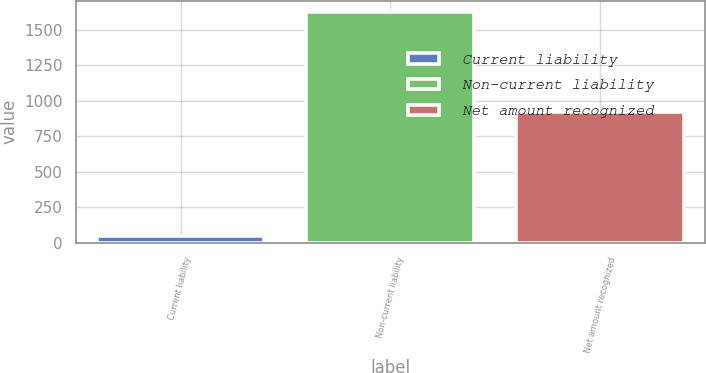Convert chart. <chart><loc_0><loc_0><loc_500><loc_500><bar_chart><fcel>Current liability<fcel>Non-current liability<fcel>Net amount recognized<nl><fcel>48<fcel>1623<fcel>923<nl></chart> 